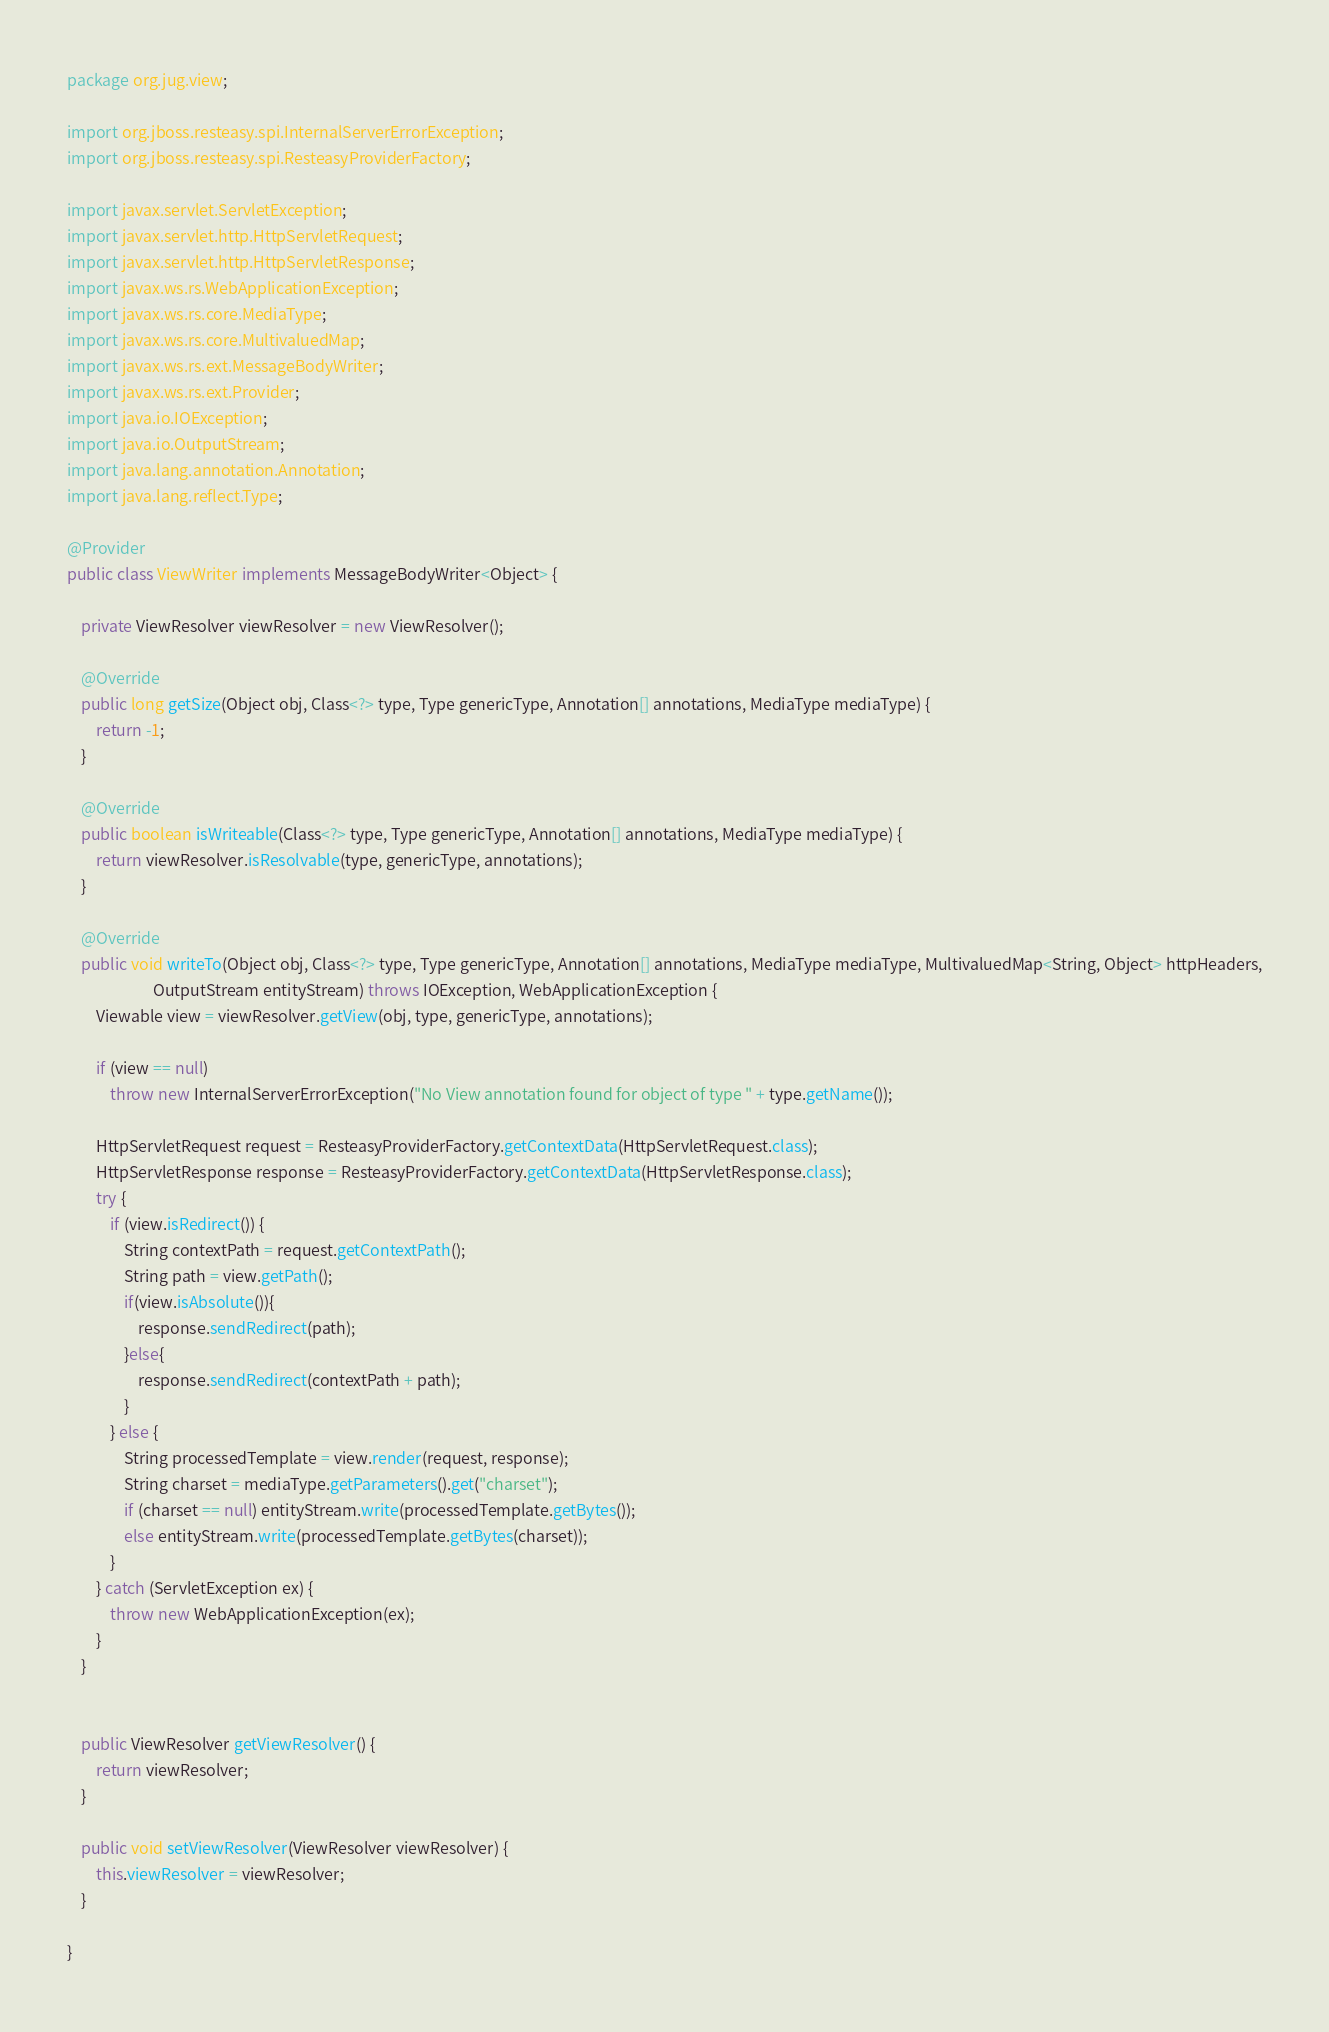<code> <loc_0><loc_0><loc_500><loc_500><_Java_>package org.jug.view;

import org.jboss.resteasy.spi.InternalServerErrorException;
import org.jboss.resteasy.spi.ResteasyProviderFactory;

import javax.servlet.ServletException;
import javax.servlet.http.HttpServletRequest;
import javax.servlet.http.HttpServletResponse;
import javax.ws.rs.WebApplicationException;
import javax.ws.rs.core.MediaType;
import javax.ws.rs.core.MultivaluedMap;
import javax.ws.rs.ext.MessageBodyWriter;
import javax.ws.rs.ext.Provider;
import java.io.IOException;
import java.io.OutputStream;
import java.lang.annotation.Annotation;
import java.lang.reflect.Type;

@Provider
public class ViewWriter implements MessageBodyWriter<Object> {

    private ViewResolver viewResolver = new ViewResolver();

    @Override
    public long getSize(Object obj, Class<?> type, Type genericType, Annotation[] annotations, MediaType mediaType) {
        return -1;
    }

    @Override
    public boolean isWriteable(Class<?> type, Type genericType, Annotation[] annotations, MediaType mediaType) {
        return viewResolver.isResolvable(type, genericType, annotations);
    }

    @Override
    public void writeTo(Object obj, Class<?> type, Type genericType, Annotation[] annotations, MediaType mediaType, MultivaluedMap<String, Object> httpHeaders,
                        OutputStream entityStream) throws IOException, WebApplicationException {
        Viewable view = viewResolver.getView(obj, type, genericType, annotations);

        if (view == null)
            throw new InternalServerErrorException("No View annotation found for object of type " + type.getName());

        HttpServletRequest request = ResteasyProviderFactory.getContextData(HttpServletRequest.class);
        HttpServletResponse response = ResteasyProviderFactory.getContextData(HttpServletResponse.class);
        try {
            if (view.isRedirect()) {
                String contextPath = request.getContextPath();
                String path = view.getPath();
                if(view.isAbsolute()){
                    response.sendRedirect(path);
                }else{
                    response.sendRedirect(contextPath + path);
                }
            } else {
                String processedTemplate = view.render(request, response);
                String charset = mediaType.getParameters().get("charset");
                if (charset == null) entityStream.write(processedTemplate.getBytes());
                else entityStream.write(processedTemplate.getBytes(charset));
            }
        } catch (ServletException ex) {
            throw new WebApplicationException(ex);
        }
    }


    public ViewResolver getViewResolver() {
        return viewResolver;
    }

    public void setViewResolver(ViewResolver viewResolver) {
        this.viewResolver = viewResolver;
    }

}
</code> 